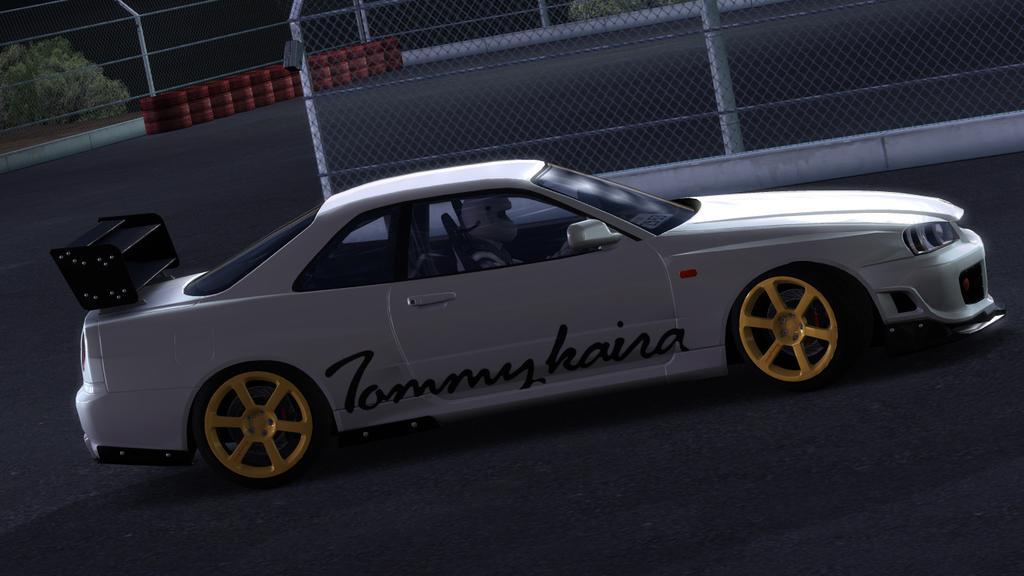Please provide a concise description of this image. At the center of the image there is a car on the road. In the background there is a mesh, behind the mesh there are some objects placed in a side of the road and some trees. 